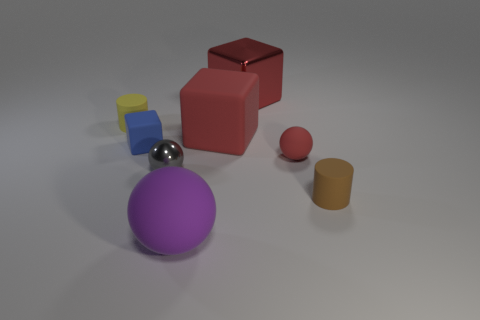Subtract all tiny spheres. How many spheres are left? 1 Subtract all red cubes. How many cubes are left? 1 Subtract all cubes. How many objects are left? 5 Add 1 cyan matte blocks. How many objects exist? 9 Subtract 0 cyan blocks. How many objects are left? 8 Subtract 3 spheres. How many spheres are left? 0 Subtract all cyan balls. Subtract all cyan blocks. How many balls are left? 3 Subtract all blue cylinders. How many purple cubes are left? 0 Subtract all blocks. Subtract all big blue rubber balls. How many objects are left? 5 Add 7 small gray balls. How many small gray balls are left? 8 